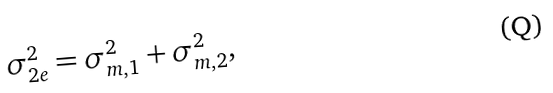Convert formula to latex. <formula><loc_0><loc_0><loc_500><loc_500>\sigma _ { 2 e } ^ { 2 } = \sigma _ { m , 1 } ^ { 2 } + \sigma _ { m , 2 } ^ { 2 } ,</formula> 